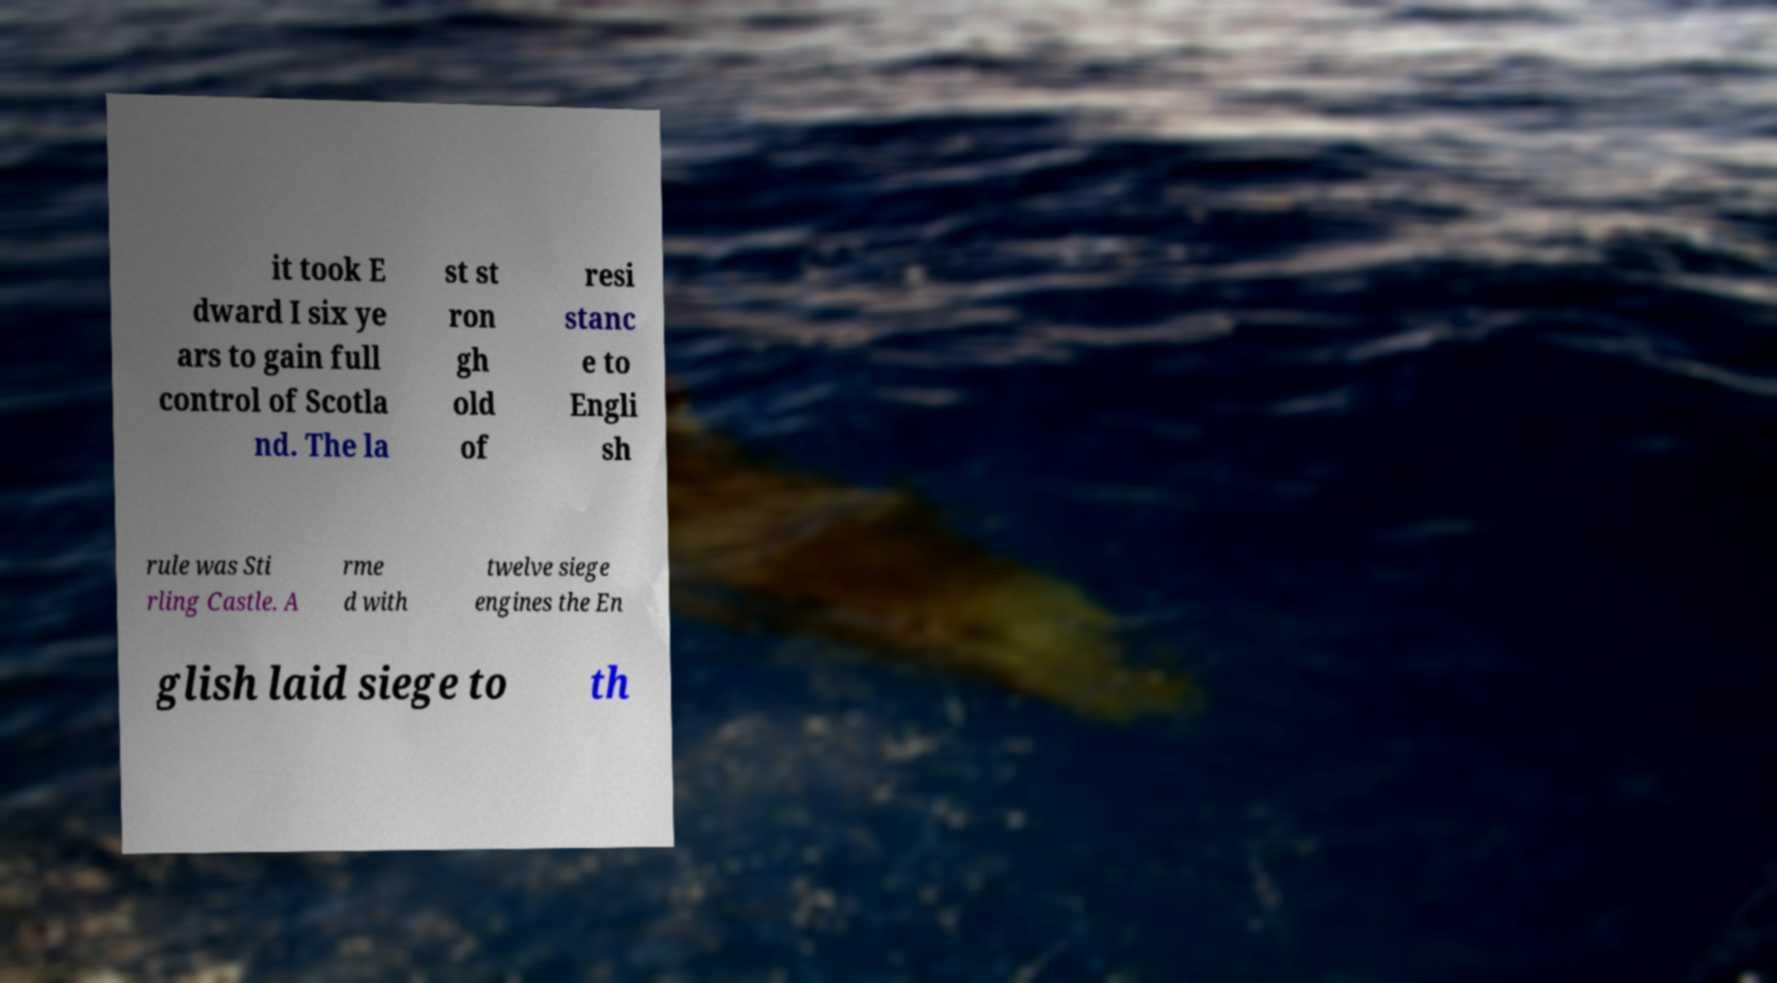Can you accurately transcribe the text from the provided image for me? it took E dward I six ye ars to gain full control of Scotla nd. The la st st ron gh old of resi stanc e to Engli sh rule was Sti rling Castle. A rme d with twelve siege engines the En glish laid siege to th 